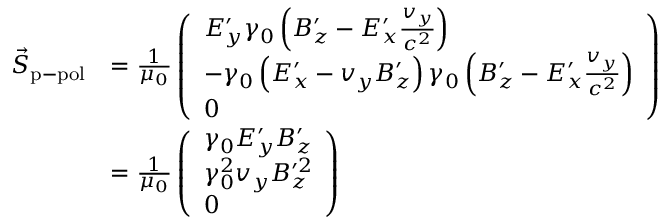Convert formula to latex. <formula><loc_0><loc_0><loc_500><loc_500>\begin{array} { r l } { \vec { S } _ { p - p o l } } & { = \frac { 1 } { \mu _ { 0 } } \left ( \begin{array} { l } { E _ { y } ^ { \prime } \gamma _ { 0 } \left ( B _ { z } ^ { \prime } - E _ { x } ^ { \prime } \frac { v _ { y } } { c ^ { 2 } } \right ) } \\ { - \gamma _ { 0 } \left ( E _ { x } ^ { \prime } - v _ { y } B _ { z } ^ { \prime } \right ) \gamma _ { 0 } \left ( B _ { z } ^ { \prime } - E _ { x } ^ { \prime } \frac { v _ { y } } { c ^ { 2 } } \right ) } \\ { 0 } \end{array} \right ) } \\ & { = \frac { 1 } { \mu _ { 0 } } \left ( \begin{array} { l } { \gamma _ { 0 } E _ { y } ^ { \prime } B _ { z } ^ { \prime } } \\ { \gamma _ { 0 } ^ { 2 } v _ { y } B _ { z } ^ { \prime 2 } } \\ { 0 } \end{array} \right ) } \end{array}</formula> 